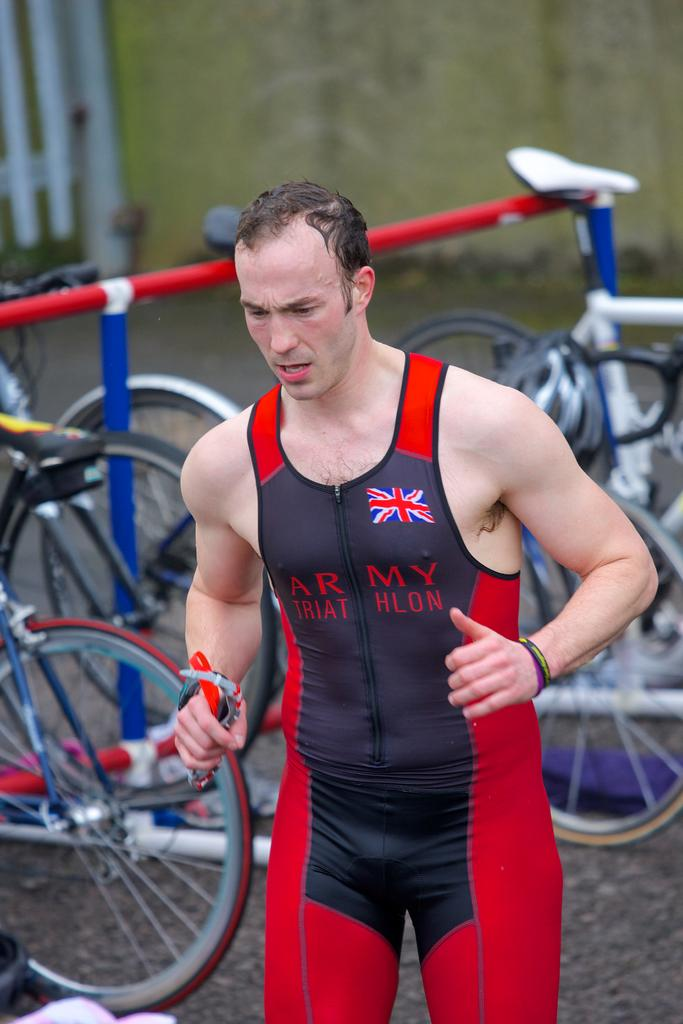<image>
Relay a brief, clear account of the picture shown. a person wearing an outfit outside with the word army on it 